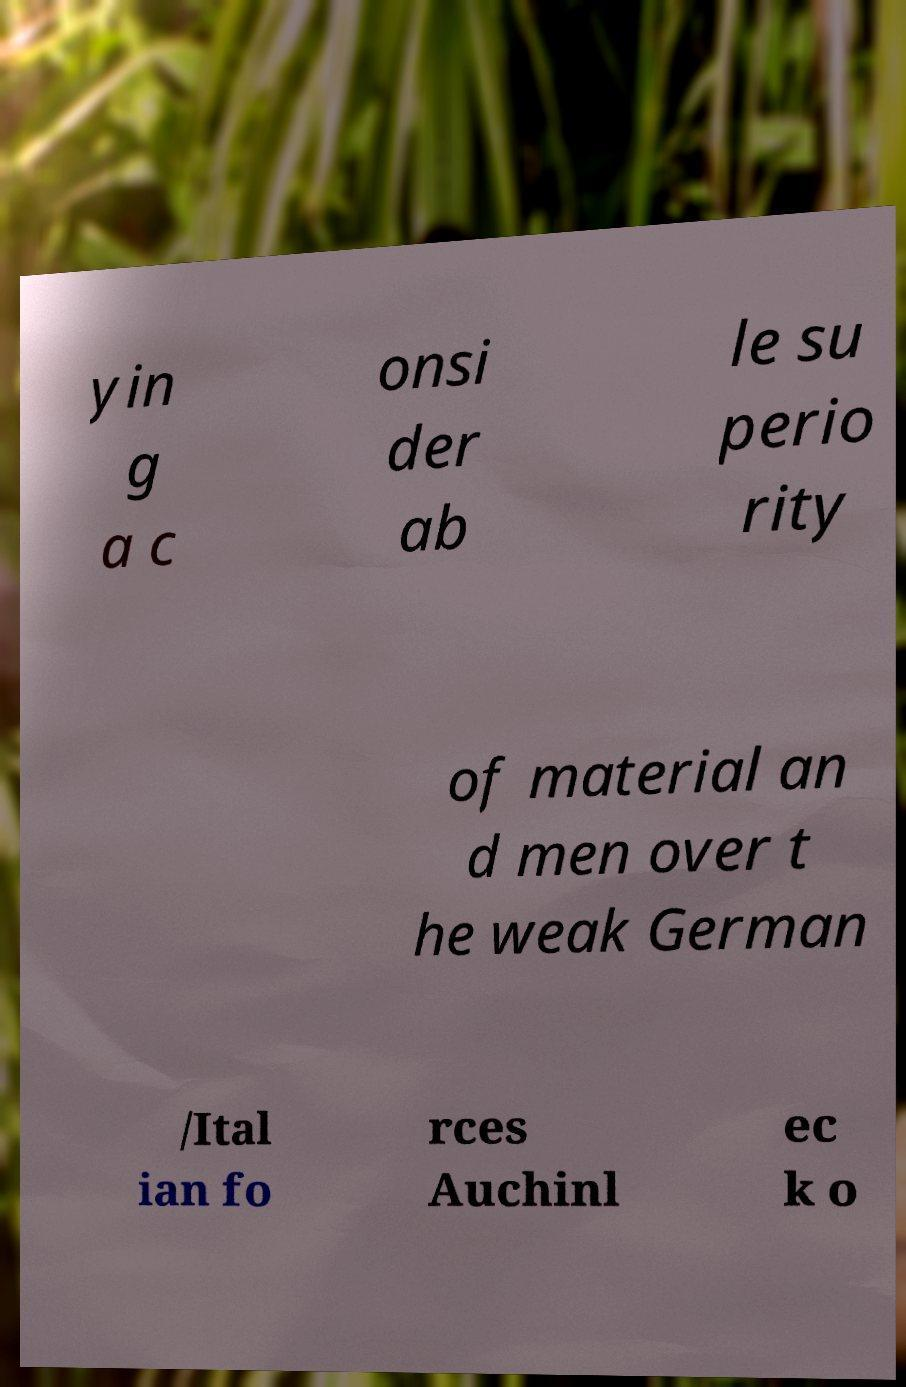Please identify and transcribe the text found in this image. yin g a c onsi der ab le su perio rity of material an d men over t he weak German /Ital ian fo rces Auchinl ec k o 